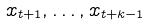Convert formula to latex. <formula><loc_0><loc_0><loc_500><loc_500>x _ { t + 1 } , \dots , x _ { t + k - 1 }</formula> 